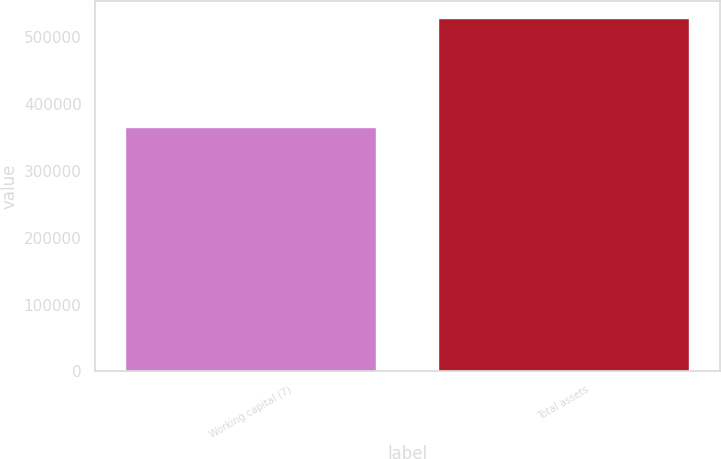<chart> <loc_0><loc_0><loc_500><loc_500><bar_chart><fcel>Working capital (7)<fcel>Total assets<nl><fcel>363787<fcel>528042<nl></chart> 